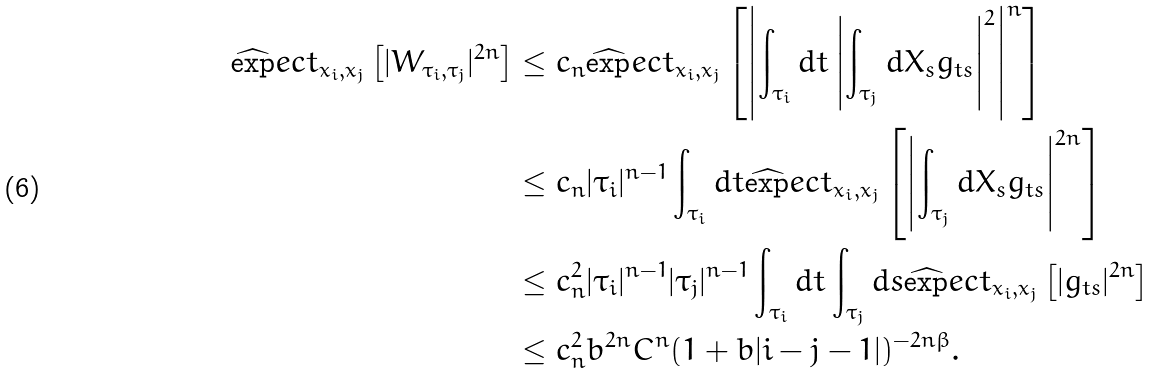<formula> <loc_0><loc_0><loc_500><loc_500>\widehat { \exp } e c t _ { x _ { i } , x _ { j } } \left [ | W _ { \tau _ { i } , \tau _ { j } } | ^ { 2 n } \right ] & \leq c _ { n } \widehat { \exp } e c t _ { x _ { i } , x _ { j } } \left [ \left | \int _ { \tau _ { i } } d t \left | \int _ { \tau _ { j } } d X _ { s } g _ { t s } \right | ^ { 2 } \right | ^ { n } \right ] \\ & \leq c _ { n } | \tau _ { i } | ^ { n - 1 } \int _ { \tau _ { i } } d t \widehat { \exp } e c t _ { x _ { i } , x _ { j } } \left [ \left | \int _ { \tau _ { j } } d X _ { s } g _ { t s } \right | ^ { 2 n } \right ] \\ & \leq c _ { n } ^ { 2 } | \tau _ { i } | ^ { n - 1 } | \tau _ { j } | ^ { n - 1 } \int _ { \tau _ { i } } d t \int _ { \tau _ { j } } d s \widehat { \exp } e c t _ { x _ { i } , x _ { j } } \left [ | g _ { t s } | ^ { 2 n } \right ] \\ & \leq c _ { n } ^ { 2 } b ^ { 2 n } C ^ { n } ( 1 + b | i - j - 1 | ) ^ { - 2 n \beta } .</formula> 